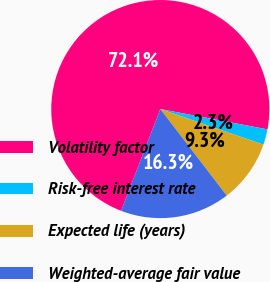<chart> <loc_0><loc_0><loc_500><loc_500><pie_chart><fcel>Volatility factor<fcel>Risk-free interest rate<fcel>Expected life (years)<fcel>Weighted-average fair value<nl><fcel>72.13%<fcel>2.31%<fcel>9.29%<fcel>16.27%<nl></chart> 